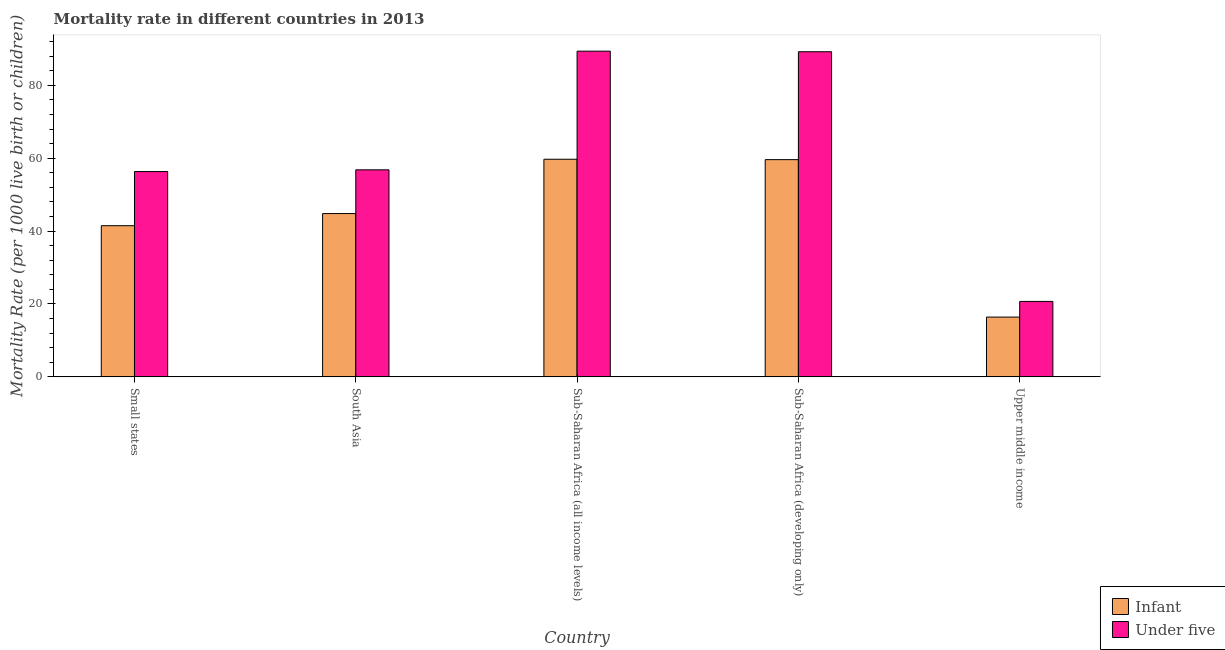How many groups of bars are there?
Provide a succinct answer. 5. Are the number of bars per tick equal to the number of legend labels?
Make the answer very short. Yes. How many bars are there on the 5th tick from the right?
Provide a succinct answer. 2. What is the label of the 3rd group of bars from the left?
Ensure brevity in your answer.  Sub-Saharan Africa (all income levels). What is the under-5 mortality rate in Sub-Saharan Africa (developing only)?
Your answer should be very brief. 89.2. Across all countries, what is the maximum under-5 mortality rate?
Give a very brief answer. 89.36. Across all countries, what is the minimum infant mortality rate?
Provide a succinct answer. 16.4. In which country was the infant mortality rate maximum?
Offer a very short reply. Sub-Saharan Africa (all income levels). In which country was the infant mortality rate minimum?
Your answer should be very brief. Upper middle income. What is the total infant mortality rate in the graph?
Ensure brevity in your answer.  221.98. What is the difference between the infant mortality rate in Small states and that in Sub-Saharan Africa (all income levels)?
Provide a short and direct response. -18.23. What is the difference between the under-5 mortality rate in Small states and the infant mortality rate in South Asia?
Make the answer very short. 11.53. What is the average infant mortality rate per country?
Offer a terse response. 44.4. What is the difference between the infant mortality rate and under-5 mortality rate in Small states?
Your answer should be compact. -14.85. What is the ratio of the under-5 mortality rate in Sub-Saharan Africa (all income levels) to that in Sub-Saharan Africa (developing only)?
Your response must be concise. 1. Is the difference between the under-5 mortality rate in Small states and Sub-Saharan Africa (all income levels) greater than the difference between the infant mortality rate in Small states and Sub-Saharan Africa (all income levels)?
Provide a succinct answer. No. What is the difference between the highest and the second highest under-5 mortality rate?
Offer a terse response. 0.16. What is the difference between the highest and the lowest infant mortality rate?
Your answer should be very brief. 43.31. What does the 2nd bar from the left in Sub-Saharan Africa (developing only) represents?
Your response must be concise. Under five. What does the 1st bar from the right in Sub-Saharan Africa (all income levels) represents?
Your answer should be very brief. Under five. How many bars are there?
Give a very brief answer. 10. How many countries are there in the graph?
Keep it short and to the point. 5. What is the difference between two consecutive major ticks on the Y-axis?
Provide a short and direct response. 20. Are the values on the major ticks of Y-axis written in scientific E-notation?
Offer a terse response. No. Does the graph contain any zero values?
Provide a succinct answer. No. Does the graph contain grids?
Keep it short and to the point. No. How many legend labels are there?
Offer a terse response. 2. What is the title of the graph?
Provide a short and direct response. Mortality rate in different countries in 2013. Does "Current education expenditure" appear as one of the legend labels in the graph?
Your answer should be very brief. No. What is the label or title of the Y-axis?
Offer a terse response. Mortality Rate (per 1000 live birth or children). What is the Mortality Rate (per 1000 live birth or children) in Infant in Small states?
Provide a short and direct response. 41.48. What is the Mortality Rate (per 1000 live birth or children) in Under five in Small states?
Provide a short and direct response. 56.33. What is the Mortality Rate (per 1000 live birth or children) of Infant in South Asia?
Your answer should be very brief. 44.8. What is the Mortality Rate (per 1000 live birth or children) in Under five in South Asia?
Offer a terse response. 56.8. What is the Mortality Rate (per 1000 live birth or children) of Infant in Sub-Saharan Africa (all income levels)?
Offer a terse response. 59.71. What is the Mortality Rate (per 1000 live birth or children) of Under five in Sub-Saharan Africa (all income levels)?
Give a very brief answer. 89.36. What is the Mortality Rate (per 1000 live birth or children) of Infant in Sub-Saharan Africa (developing only)?
Your answer should be very brief. 59.6. What is the Mortality Rate (per 1000 live birth or children) of Under five in Sub-Saharan Africa (developing only)?
Your answer should be very brief. 89.2. What is the Mortality Rate (per 1000 live birth or children) in Infant in Upper middle income?
Give a very brief answer. 16.4. What is the Mortality Rate (per 1000 live birth or children) of Under five in Upper middle income?
Keep it short and to the point. 20.7. Across all countries, what is the maximum Mortality Rate (per 1000 live birth or children) of Infant?
Keep it short and to the point. 59.71. Across all countries, what is the maximum Mortality Rate (per 1000 live birth or children) of Under five?
Offer a terse response. 89.36. Across all countries, what is the minimum Mortality Rate (per 1000 live birth or children) in Infant?
Provide a succinct answer. 16.4. Across all countries, what is the minimum Mortality Rate (per 1000 live birth or children) in Under five?
Offer a terse response. 20.7. What is the total Mortality Rate (per 1000 live birth or children) of Infant in the graph?
Ensure brevity in your answer.  221.98. What is the total Mortality Rate (per 1000 live birth or children) of Under five in the graph?
Make the answer very short. 312.39. What is the difference between the Mortality Rate (per 1000 live birth or children) in Infant in Small states and that in South Asia?
Ensure brevity in your answer.  -3.32. What is the difference between the Mortality Rate (per 1000 live birth or children) in Under five in Small states and that in South Asia?
Your response must be concise. -0.47. What is the difference between the Mortality Rate (per 1000 live birth or children) of Infant in Small states and that in Sub-Saharan Africa (all income levels)?
Make the answer very short. -18.23. What is the difference between the Mortality Rate (per 1000 live birth or children) of Under five in Small states and that in Sub-Saharan Africa (all income levels)?
Offer a very short reply. -33.03. What is the difference between the Mortality Rate (per 1000 live birth or children) in Infant in Small states and that in Sub-Saharan Africa (developing only)?
Your response must be concise. -18.12. What is the difference between the Mortality Rate (per 1000 live birth or children) of Under five in Small states and that in Sub-Saharan Africa (developing only)?
Ensure brevity in your answer.  -32.87. What is the difference between the Mortality Rate (per 1000 live birth or children) in Infant in Small states and that in Upper middle income?
Your answer should be compact. 25.08. What is the difference between the Mortality Rate (per 1000 live birth or children) in Under five in Small states and that in Upper middle income?
Your response must be concise. 35.63. What is the difference between the Mortality Rate (per 1000 live birth or children) of Infant in South Asia and that in Sub-Saharan Africa (all income levels)?
Your response must be concise. -14.91. What is the difference between the Mortality Rate (per 1000 live birth or children) in Under five in South Asia and that in Sub-Saharan Africa (all income levels)?
Provide a short and direct response. -32.56. What is the difference between the Mortality Rate (per 1000 live birth or children) in Infant in South Asia and that in Sub-Saharan Africa (developing only)?
Provide a succinct answer. -14.8. What is the difference between the Mortality Rate (per 1000 live birth or children) of Under five in South Asia and that in Sub-Saharan Africa (developing only)?
Offer a very short reply. -32.4. What is the difference between the Mortality Rate (per 1000 live birth or children) in Infant in South Asia and that in Upper middle income?
Provide a succinct answer. 28.4. What is the difference between the Mortality Rate (per 1000 live birth or children) of Under five in South Asia and that in Upper middle income?
Offer a terse response. 36.1. What is the difference between the Mortality Rate (per 1000 live birth or children) in Infant in Sub-Saharan Africa (all income levels) and that in Sub-Saharan Africa (developing only)?
Your answer should be very brief. 0.11. What is the difference between the Mortality Rate (per 1000 live birth or children) of Under five in Sub-Saharan Africa (all income levels) and that in Sub-Saharan Africa (developing only)?
Offer a terse response. 0.16. What is the difference between the Mortality Rate (per 1000 live birth or children) of Infant in Sub-Saharan Africa (all income levels) and that in Upper middle income?
Your answer should be very brief. 43.31. What is the difference between the Mortality Rate (per 1000 live birth or children) of Under five in Sub-Saharan Africa (all income levels) and that in Upper middle income?
Your answer should be very brief. 68.66. What is the difference between the Mortality Rate (per 1000 live birth or children) of Infant in Sub-Saharan Africa (developing only) and that in Upper middle income?
Your answer should be very brief. 43.2. What is the difference between the Mortality Rate (per 1000 live birth or children) in Under five in Sub-Saharan Africa (developing only) and that in Upper middle income?
Give a very brief answer. 68.5. What is the difference between the Mortality Rate (per 1000 live birth or children) in Infant in Small states and the Mortality Rate (per 1000 live birth or children) in Under five in South Asia?
Provide a short and direct response. -15.32. What is the difference between the Mortality Rate (per 1000 live birth or children) in Infant in Small states and the Mortality Rate (per 1000 live birth or children) in Under five in Sub-Saharan Africa (all income levels)?
Your response must be concise. -47.88. What is the difference between the Mortality Rate (per 1000 live birth or children) in Infant in Small states and the Mortality Rate (per 1000 live birth or children) in Under five in Sub-Saharan Africa (developing only)?
Keep it short and to the point. -47.72. What is the difference between the Mortality Rate (per 1000 live birth or children) in Infant in Small states and the Mortality Rate (per 1000 live birth or children) in Under five in Upper middle income?
Provide a short and direct response. 20.78. What is the difference between the Mortality Rate (per 1000 live birth or children) in Infant in South Asia and the Mortality Rate (per 1000 live birth or children) in Under five in Sub-Saharan Africa (all income levels)?
Make the answer very short. -44.56. What is the difference between the Mortality Rate (per 1000 live birth or children) in Infant in South Asia and the Mortality Rate (per 1000 live birth or children) in Under five in Sub-Saharan Africa (developing only)?
Provide a succinct answer. -44.4. What is the difference between the Mortality Rate (per 1000 live birth or children) of Infant in South Asia and the Mortality Rate (per 1000 live birth or children) of Under five in Upper middle income?
Ensure brevity in your answer.  24.1. What is the difference between the Mortality Rate (per 1000 live birth or children) in Infant in Sub-Saharan Africa (all income levels) and the Mortality Rate (per 1000 live birth or children) in Under five in Sub-Saharan Africa (developing only)?
Your response must be concise. -29.49. What is the difference between the Mortality Rate (per 1000 live birth or children) of Infant in Sub-Saharan Africa (all income levels) and the Mortality Rate (per 1000 live birth or children) of Under five in Upper middle income?
Provide a short and direct response. 39.01. What is the difference between the Mortality Rate (per 1000 live birth or children) of Infant in Sub-Saharan Africa (developing only) and the Mortality Rate (per 1000 live birth or children) of Under five in Upper middle income?
Your response must be concise. 38.9. What is the average Mortality Rate (per 1000 live birth or children) of Infant per country?
Make the answer very short. 44.4. What is the average Mortality Rate (per 1000 live birth or children) of Under five per country?
Your response must be concise. 62.48. What is the difference between the Mortality Rate (per 1000 live birth or children) of Infant and Mortality Rate (per 1000 live birth or children) of Under five in Small states?
Provide a short and direct response. -14.85. What is the difference between the Mortality Rate (per 1000 live birth or children) in Infant and Mortality Rate (per 1000 live birth or children) in Under five in South Asia?
Offer a terse response. -12. What is the difference between the Mortality Rate (per 1000 live birth or children) of Infant and Mortality Rate (per 1000 live birth or children) of Under five in Sub-Saharan Africa (all income levels)?
Keep it short and to the point. -29.65. What is the difference between the Mortality Rate (per 1000 live birth or children) of Infant and Mortality Rate (per 1000 live birth or children) of Under five in Sub-Saharan Africa (developing only)?
Give a very brief answer. -29.6. What is the difference between the Mortality Rate (per 1000 live birth or children) in Infant and Mortality Rate (per 1000 live birth or children) in Under five in Upper middle income?
Your answer should be compact. -4.3. What is the ratio of the Mortality Rate (per 1000 live birth or children) of Infant in Small states to that in South Asia?
Give a very brief answer. 0.93. What is the ratio of the Mortality Rate (per 1000 live birth or children) in Under five in Small states to that in South Asia?
Offer a very short reply. 0.99. What is the ratio of the Mortality Rate (per 1000 live birth or children) in Infant in Small states to that in Sub-Saharan Africa (all income levels)?
Offer a very short reply. 0.69. What is the ratio of the Mortality Rate (per 1000 live birth or children) of Under five in Small states to that in Sub-Saharan Africa (all income levels)?
Give a very brief answer. 0.63. What is the ratio of the Mortality Rate (per 1000 live birth or children) of Infant in Small states to that in Sub-Saharan Africa (developing only)?
Keep it short and to the point. 0.7. What is the ratio of the Mortality Rate (per 1000 live birth or children) in Under five in Small states to that in Sub-Saharan Africa (developing only)?
Ensure brevity in your answer.  0.63. What is the ratio of the Mortality Rate (per 1000 live birth or children) of Infant in Small states to that in Upper middle income?
Provide a short and direct response. 2.53. What is the ratio of the Mortality Rate (per 1000 live birth or children) of Under five in Small states to that in Upper middle income?
Provide a short and direct response. 2.72. What is the ratio of the Mortality Rate (per 1000 live birth or children) in Infant in South Asia to that in Sub-Saharan Africa (all income levels)?
Your answer should be compact. 0.75. What is the ratio of the Mortality Rate (per 1000 live birth or children) of Under five in South Asia to that in Sub-Saharan Africa (all income levels)?
Keep it short and to the point. 0.64. What is the ratio of the Mortality Rate (per 1000 live birth or children) in Infant in South Asia to that in Sub-Saharan Africa (developing only)?
Ensure brevity in your answer.  0.75. What is the ratio of the Mortality Rate (per 1000 live birth or children) of Under five in South Asia to that in Sub-Saharan Africa (developing only)?
Offer a very short reply. 0.64. What is the ratio of the Mortality Rate (per 1000 live birth or children) in Infant in South Asia to that in Upper middle income?
Offer a terse response. 2.73. What is the ratio of the Mortality Rate (per 1000 live birth or children) in Under five in South Asia to that in Upper middle income?
Offer a terse response. 2.74. What is the ratio of the Mortality Rate (per 1000 live birth or children) in Infant in Sub-Saharan Africa (all income levels) to that in Upper middle income?
Your answer should be compact. 3.64. What is the ratio of the Mortality Rate (per 1000 live birth or children) of Under five in Sub-Saharan Africa (all income levels) to that in Upper middle income?
Your answer should be very brief. 4.32. What is the ratio of the Mortality Rate (per 1000 live birth or children) of Infant in Sub-Saharan Africa (developing only) to that in Upper middle income?
Your answer should be very brief. 3.63. What is the ratio of the Mortality Rate (per 1000 live birth or children) in Under five in Sub-Saharan Africa (developing only) to that in Upper middle income?
Give a very brief answer. 4.31. What is the difference between the highest and the second highest Mortality Rate (per 1000 live birth or children) of Infant?
Ensure brevity in your answer.  0.11. What is the difference between the highest and the second highest Mortality Rate (per 1000 live birth or children) in Under five?
Make the answer very short. 0.16. What is the difference between the highest and the lowest Mortality Rate (per 1000 live birth or children) in Infant?
Provide a succinct answer. 43.31. What is the difference between the highest and the lowest Mortality Rate (per 1000 live birth or children) in Under five?
Give a very brief answer. 68.66. 